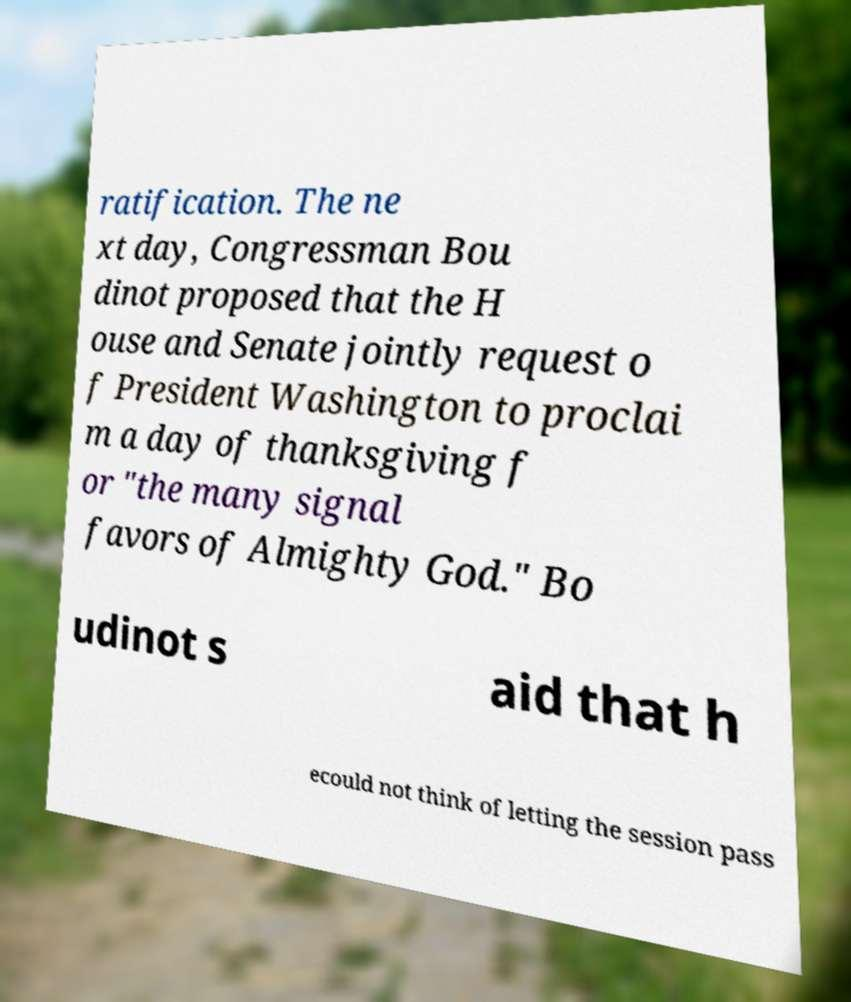Please read and relay the text visible in this image. What does it say? ratification. The ne xt day, Congressman Bou dinot proposed that the H ouse and Senate jointly request o f President Washington to proclai m a day of thanksgiving f or "the many signal favors of Almighty God." Bo udinot s aid that h ecould not think of letting the session pass 